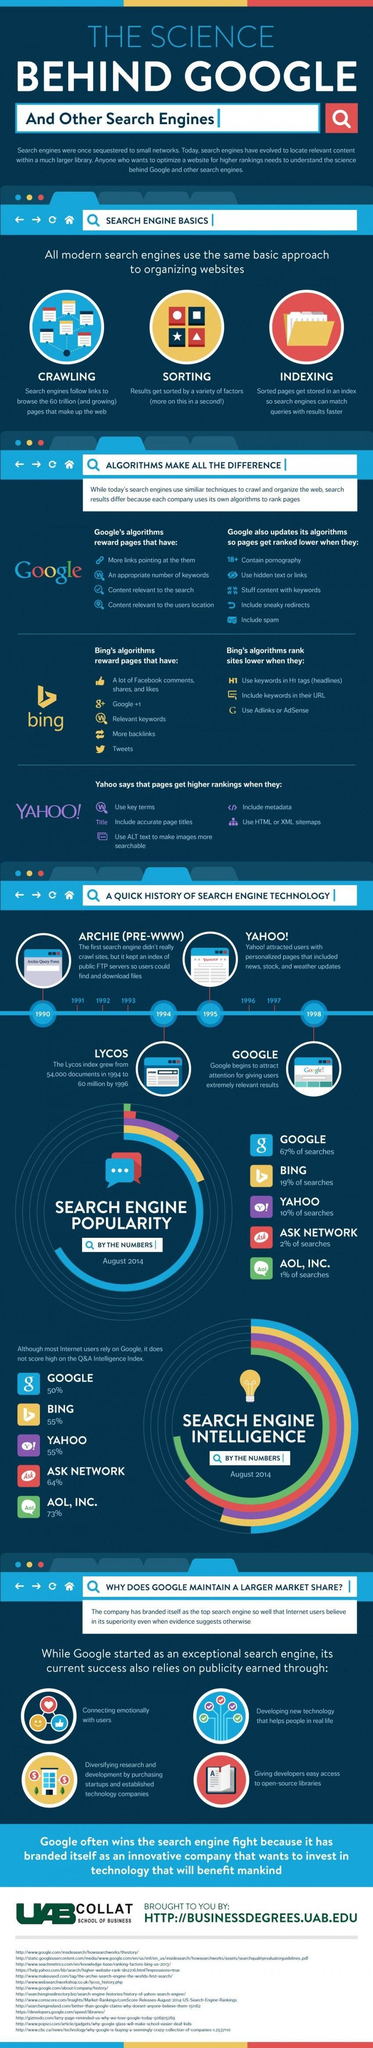Give some essential details in this illustration. Bing is the second most popular search engine, according to search engine popularity. Pre-1995, search technologies such as Archie and Lycos were used to facilitate web navigation. All search engines, including Bing and Yahoo, have the same Q&A intelligence index. There were only two search engine technologies in use prior to 1995. It is reported that only two search engines have a search engine popularity of less than 10%. 